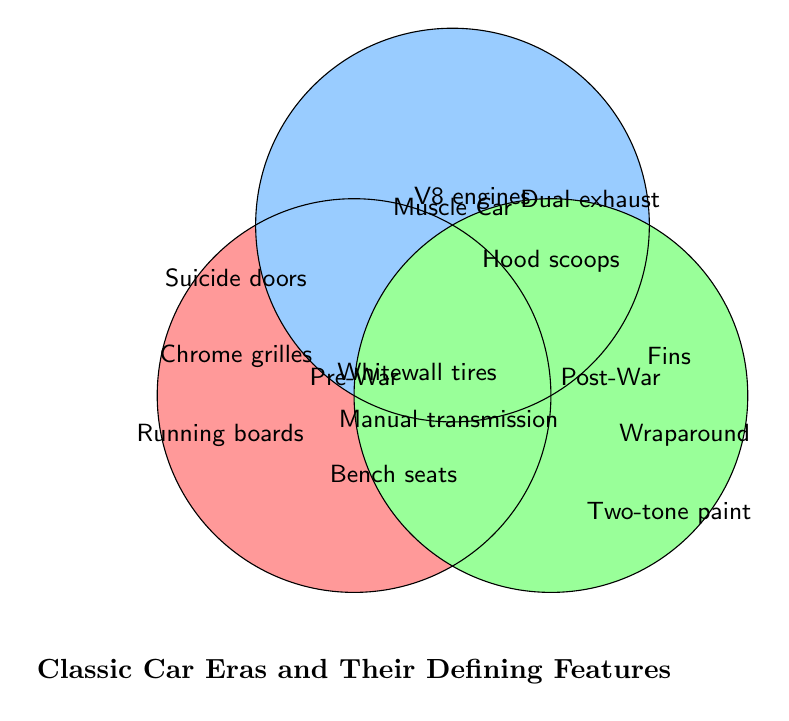What's the title of the Venn Diagram? The title is clearly displayed at the bottom of the diagram where the bold font text is located.
Answer: Classic Car Eras and Their Defining Features Which car era has the feature "Chrome grilles"? The feature "Chrome grilles" is located within the leftmost circle, labeled "Pre-War."
Answer: Pre-War Name all features common to both the Pre-War and Muscle Car eras. The features in the overlapping area between the Pre-War and Muscle Car eras include "Whitewall tires," "Manual transmission," and "Bench seats."
Answer: Whitewall tires, Manual transmission, Bench seats Which era is associated with "Fins"? The feature "Fins" is located in the rightmost circle, which is labeled "Post-War."
Answer: Post-War Which eras share the "Manual transmission" feature? The feature "Manual transmission" appears in the overlapping region common to the Pre-War, Muscle Car, and Post-War eras.
Answer: Pre-War, Muscle Car, Post-War Is the feature "Dual exhaust" associated with the Pre-War era? "Dual exhaust" is located within the top circle labeled "Muscle Car," and not within the overlapping areas involving Pre-War.
Answer: No What are the features unique to the Post-War era? The features that are entirely within the "Post-War" circle and not shared are "Fins," "Wraparound windshields," and "Two-tone paint."
Answer: Fins, Wraparound windshields, Two-tone paint Which car era includes "Hood scoops"? "Hood scoops" is positioned in the top circle labeled "Muscle Car."
Answer: Muscle Car Between Muscle Cars and Post-War, which era has more unique features? Muscle Car has three unique features ("V8 engines," "Hood scoops," "Dual exhaust") and Post-War also has three unique features ("Fins," "Wraparound windshields," "Two-tone paint"). Both have the same number of unique features.
Answer: Equal Name one feature that all three car eras (Pre-War, Muscle Car, Post-War) share. All three eras share the feature "Manual transmission," visible in the triple overlapping region of the Venn Diagram.
Answer: Manual transmission 